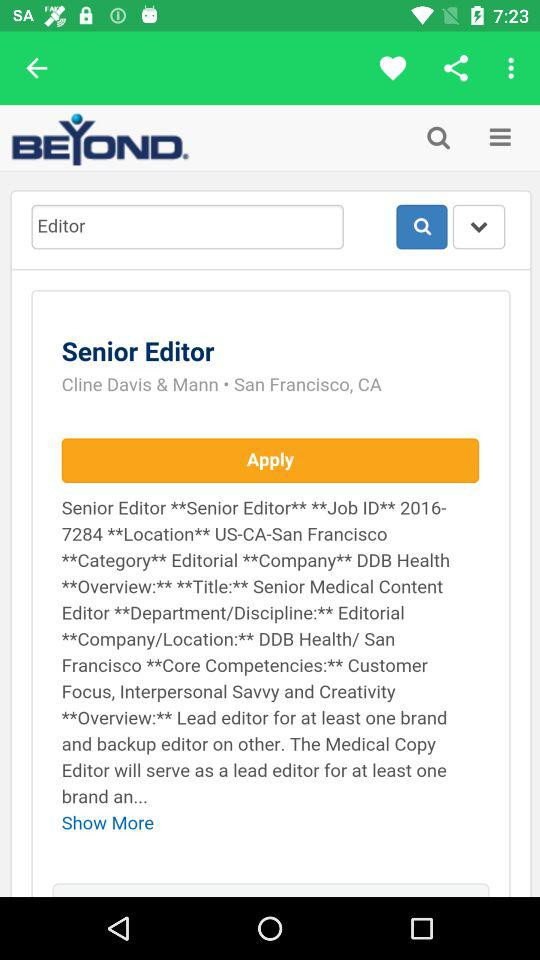What is the name of the application? The name of the application is "BEYOND". 